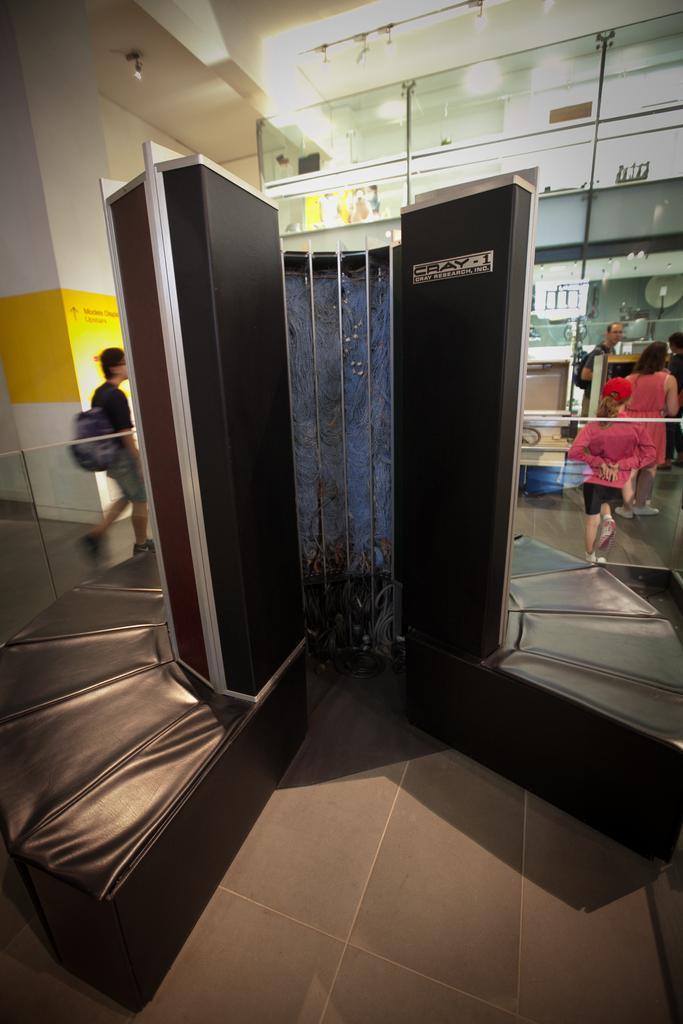How would you summarize this image in a sentence or two? In this image it is looking like cupboard cum sofa. I can see few people. In the background I can see few glasses and lights. 